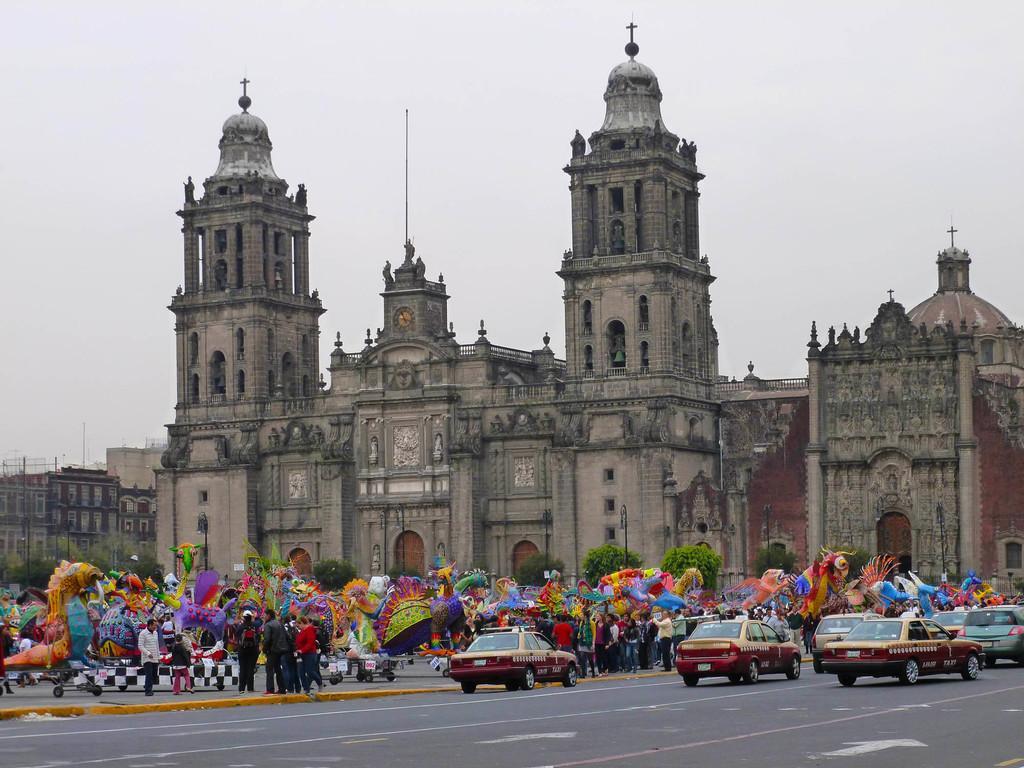Could you give a brief overview of what you see in this image? In this picture we can see some cars on the road, on the left side there are some people standing, we can see buildings and trees in the background, it looks like carnival in the middle, there is the sky at the top of the picture. 